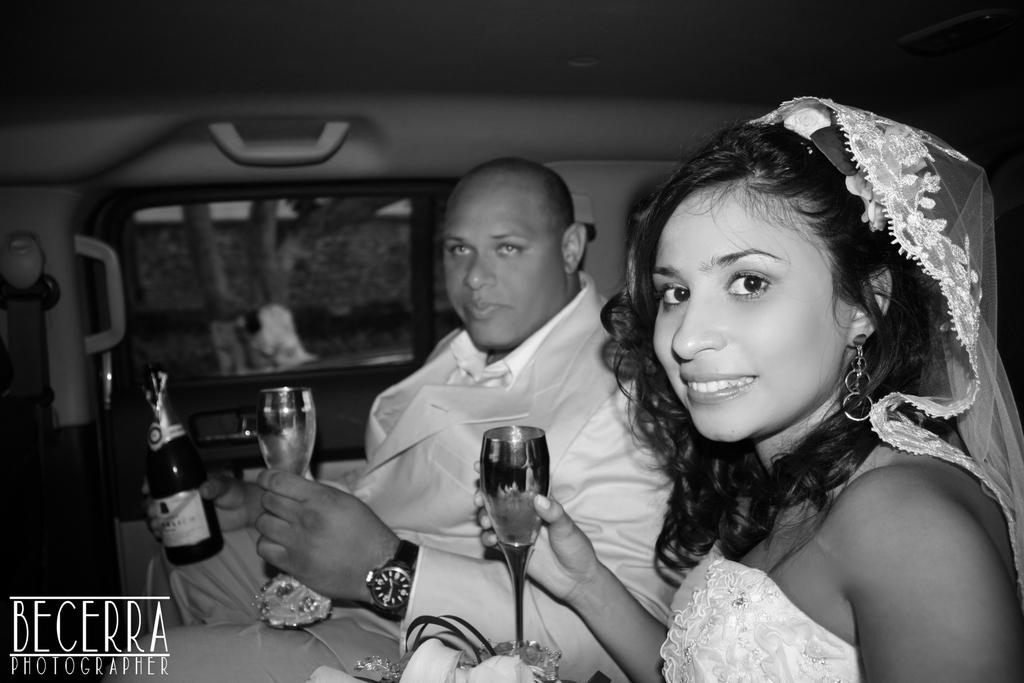Who is present in the image? There is a man and a woman in the image. Where are they located? They are sitting inside a vehicle. What is the man holding in the image? The man is holding a bottle. What is the woman holding in the image? The woman is holding a glass. How does the woman appear in the image? The woman is smiling. What type of belief can be seen on the man's ear in the image? There is no mention of a belief or an ear in the image; the man is holding a bottle and the woman is holding a glass. 